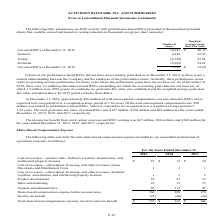According to Activision Blizzard's financial document, What was the cost of revenues from product sales in 2019? According to the financial document, $19 (in millions). The relevant text states: "Unvested RSUs at December 31, 2019 9,328 $ 32.60..." Also, What was the cost of revenues from product sales in 2018? According to the financial document, $13 (in millions). The relevant text states: "zation, and intellectual property licenses $ 19 $ 13 $ 10..." Also, What was the sales and marketing in 2017? According to the financial document, 15 (in millions). The relevant text states: "Sales and marketing 10 15 15..." Also, can you calculate: What was the change in sales and marketing between 2018 and 2019? Based on the calculation: 10-15, the result is -5 (in millions). This is based on the information: "Sales and marketing 10 15 15 Sales and marketing 10 15 15..." The key data points involved are: 10, 15. Also, can you calculate: What was the change in product development between 2018 and 2019? Based on the calculation: 53-61, the result is -8 (in millions). This is based on the information: "Product development 53 61 57 Product development 53 61 57..." The key data points involved are: 53, 61. Also, can you calculate: What was the percentage change in General and administrative expenses between 2017 and 2018? To answer this question, I need to perform calculations using the financial data. The calculation is: (115-92)/92, which equals 25 (percentage). This is based on the information: "General and administrative 82 115 92 General and administrative 82 115 92..." The key data points involved are: 115, 92. 